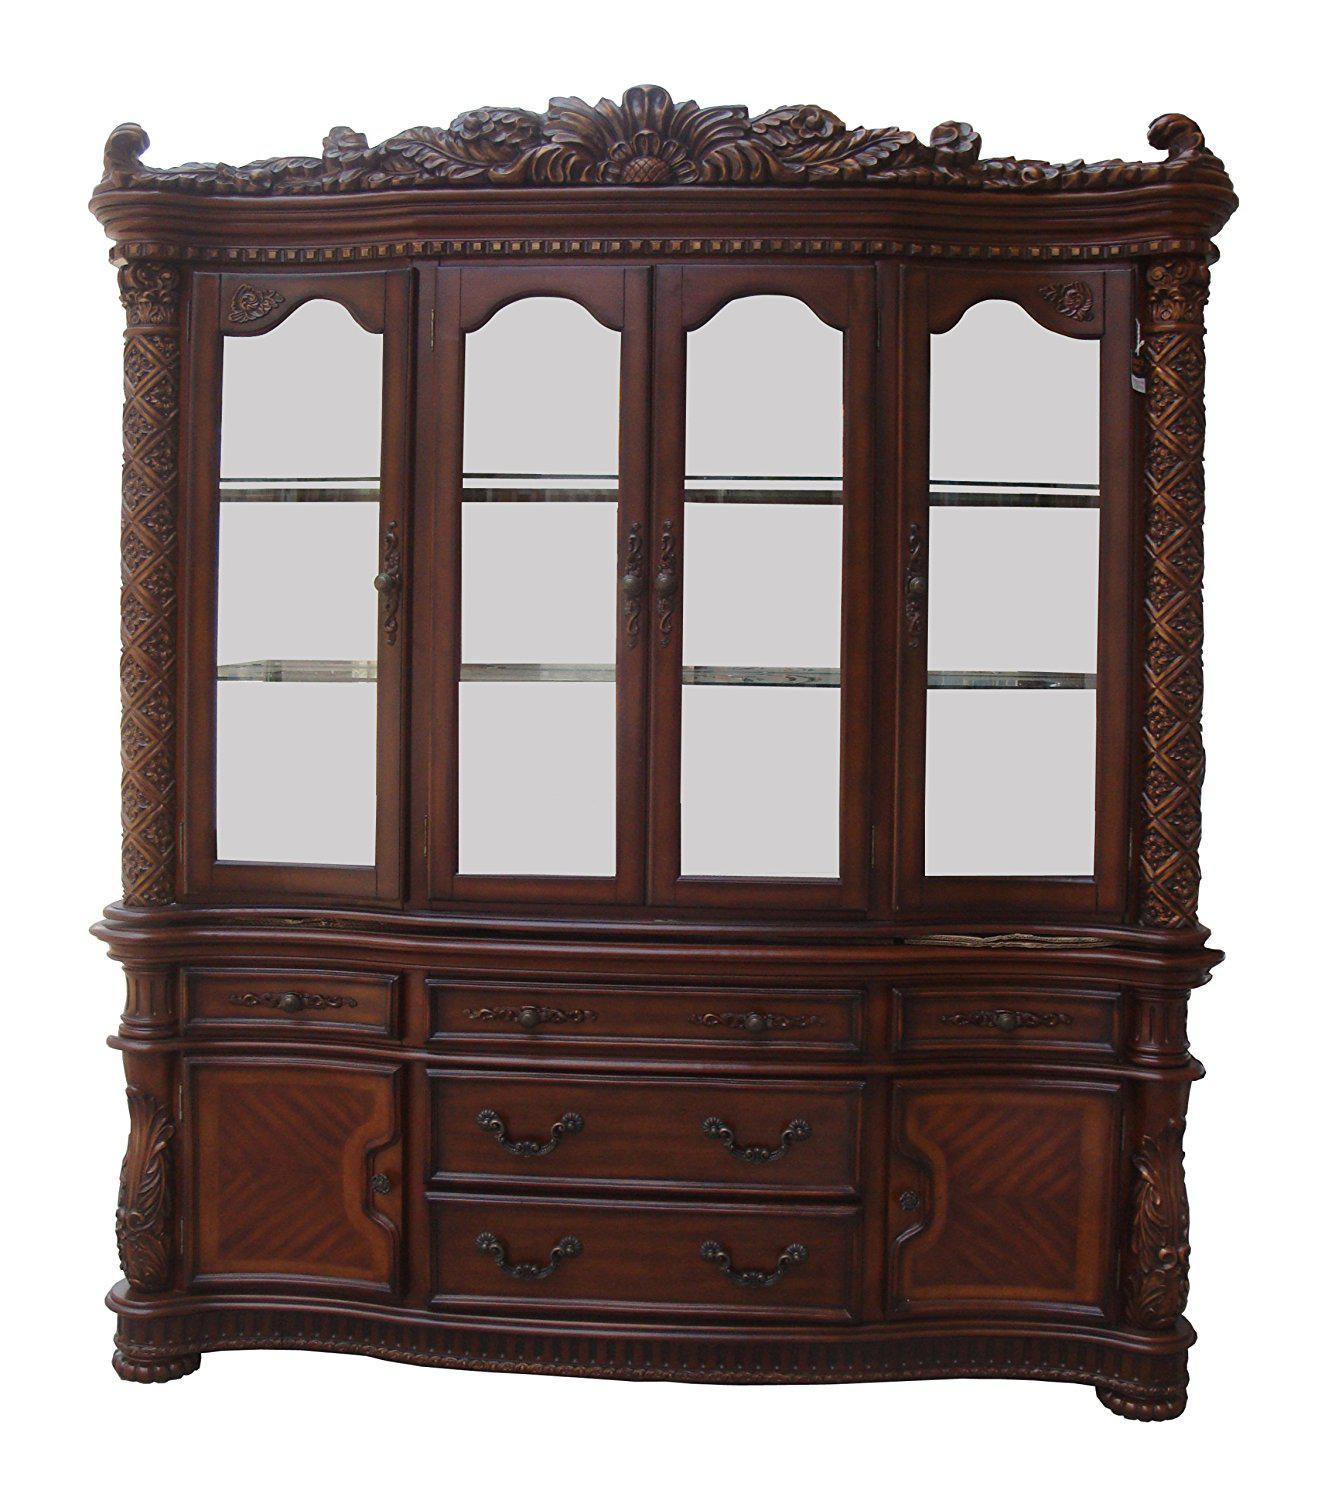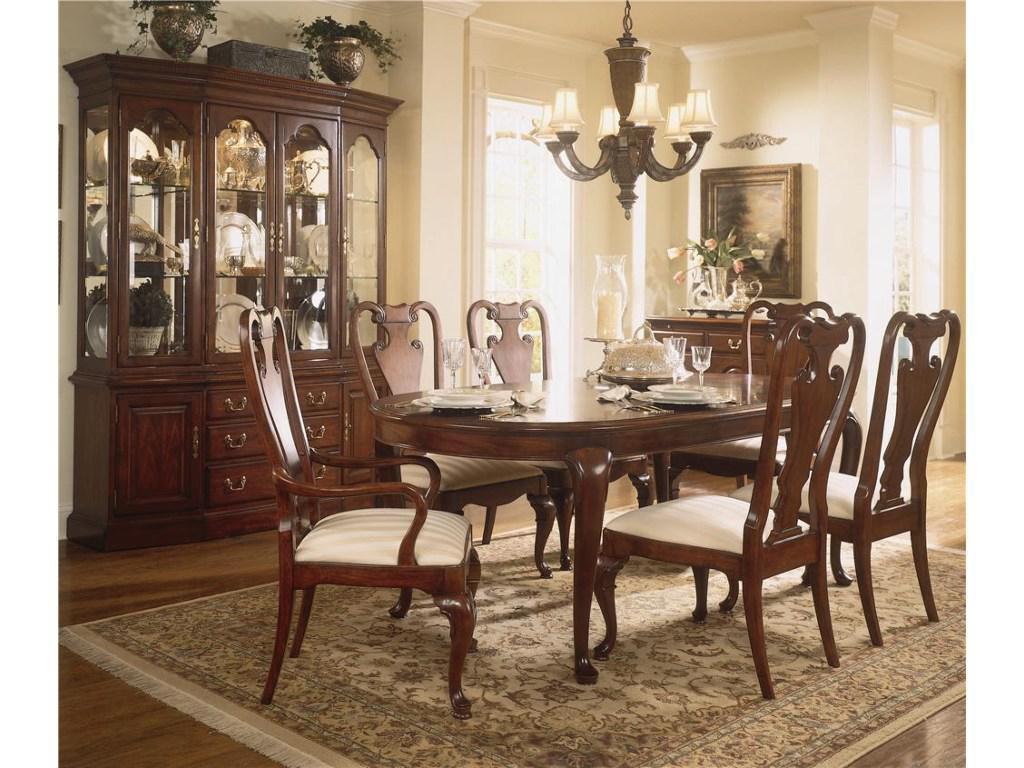The first image is the image on the left, the second image is the image on the right. For the images displayed, is the sentence "One of the cabinet fronts is not flat across the top." factually correct? Answer yes or no. Yes. 